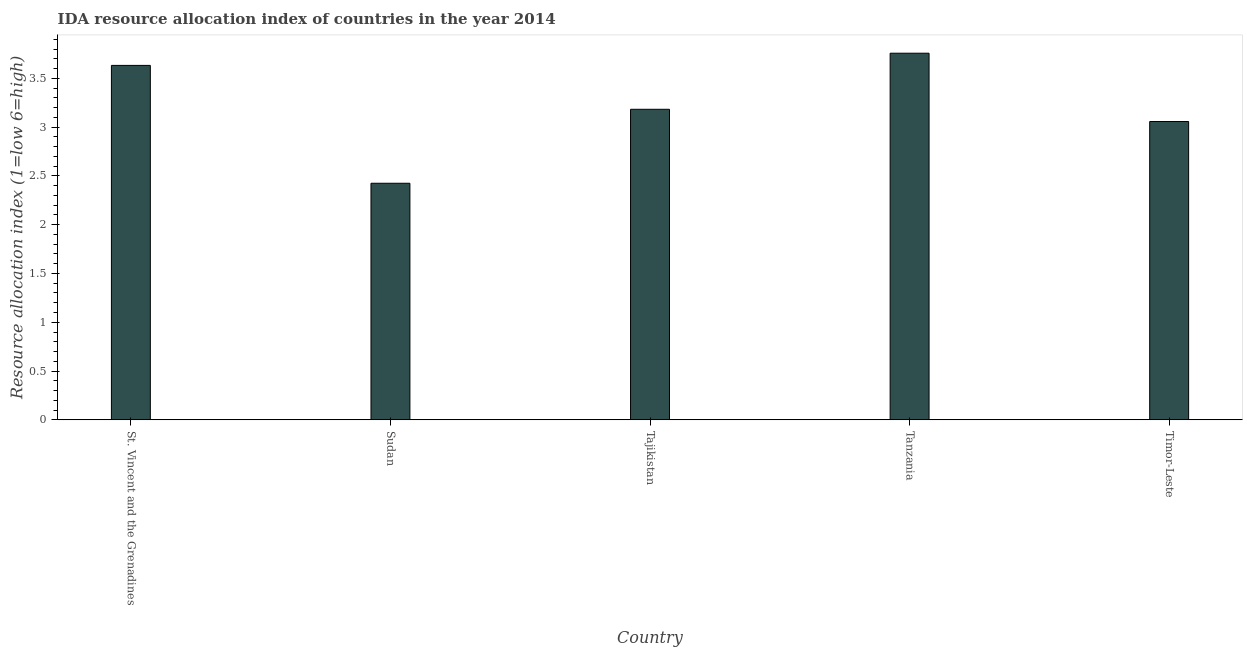Does the graph contain grids?
Give a very brief answer. No. What is the title of the graph?
Make the answer very short. IDA resource allocation index of countries in the year 2014. What is the label or title of the X-axis?
Your answer should be very brief. Country. What is the label or title of the Y-axis?
Make the answer very short. Resource allocation index (1=low 6=high). What is the ida resource allocation index in Sudan?
Your answer should be very brief. 2.42. Across all countries, what is the maximum ida resource allocation index?
Ensure brevity in your answer.  3.76. Across all countries, what is the minimum ida resource allocation index?
Provide a succinct answer. 2.42. In which country was the ida resource allocation index maximum?
Offer a terse response. Tanzania. In which country was the ida resource allocation index minimum?
Your response must be concise. Sudan. What is the sum of the ida resource allocation index?
Give a very brief answer. 16.06. What is the difference between the ida resource allocation index in Tajikistan and Tanzania?
Offer a terse response. -0.57. What is the average ida resource allocation index per country?
Offer a terse response. 3.21. What is the median ida resource allocation index?
Your answer should be very brief. 3.18. What is the ratio of the ida resource allocation index in Sudan to that in Timor-Leste?
Make the answer very short. 0.79. Is the ida resource allocation index in St. Vincent and the Grenadines less than that in Tajikistan?
Give a very brief answer. No. What is the difference between the highest and the second highest ida resource allocation index?
Offer a very short reply. 0.12. Is the sum of the ida resource allocation index in Sudan and Tajikistan greater than the maximum ida resource allocation index across all countries?
Offer a very short reply. Yes. What is the difference between the highest and the lowest ida resource allocation index?
Provide a succinct answer. 1.33. How many bars are there?
Provide a succinct answer. 5. Are all the bars in the graph horizontal?
Your answer should be very brief. No. What is the Resource allocation index (1=low 6=high) in St. Vincent and the Grenadines?
Keep it short and to the point. 3.63. What is the Resource allocation index (1=low 6=high) of Sudan?
Offer a very short reply. 2.42. What is the Resource allocation index (1=low 6=high) in Tajikistan?
Ensure brevity in your answer.  3.18. What is the Resource allocation index (1=low 6=high) in Tanzania?
Offer a terse response. 3.76. What is the Resource allocation index (1=low 6=high) of Timor-Leste?
Offer a very short reply. 3.06. What is the difference between the Resource allocation index (1=low 6=high) in St. Vincent and the Grenadines and Sudan?
Make the answer very short. 1.21. What is the difference between the Resource allocation index (1=low 6=high) in St. Vincent and the Grenadines and Tajikistan?
Your answer should be compact. 0.45. What is the difference between the Resource allocation index (1=low 6=high) in St. Vincent and the Grenadines and Tanzania?
Provide a succinct answer. -0.12. What is the difference between the Resource allocation index (1=low 6=high) in St. Vincent and the Grenadines and Timor-Leste?
Your answer should be compact. 0.57. What is the difference between the Resource allocation index (1=low 6=high) in Sudan and Tajikistan?
Provide a succinct answer. -0.76. What is the difference between the Resource allocation index (1=low 6=high) in Sudan and Tanzania?
Make the answer very short. -1.33. What is the difference between the Resource allocation index (1=low 6=high) in Sudan and Timor-Leste?
Make the answer very short. -0.63. What is the difference between the Resource allocation index (1=low 6=high) in Tajikistan and Tanzania?
Your answer should be compact. -0.57. What is the ratio of the Resource allocation index (1=low 6=high) in St. Vincent and the Grenadines to that in Sudan?
Provide a succinct answer. 1.5. What is the ratio of the Resource allocation index (1=low 6=high) in St. Vincent and the Grenadines to that in Tajikistan?
Your response must be concise. 1.14. What is the ratio of the Resource allocation index (1=low 6=high) in St. Vincent and the Grenadines to that in Tanzania?
Your answer should be compact. 0.97. What is the ratio of the Resource allocation index (1=low 6=high) in St. Vincent and the Grenadines to that in Timor-Leste?
Your answer should be compact. 1.19. What is the ratio of the Resource allocation index (1=low 6=high) in Sudan to that in Tajikistan?
Offer a terse response. 0.76. What is the ratio of the Resource allocation index (1=low 6=high) in Sudan to that in Tanzania?
Give a very brief answer. 0.65. What is the ratio of the Resource allocation index (1=low 6=high) in Sudan to that in Timor-Leste?
Your answer should be very brief. 0.79. What is the ratio of the Resource allocation index (1=low 6=high) in Tajikistan to that in Tanzania?
Ensure brevity in your answer.  0.85. What is the ratio of the Resource allocation index (1=low 6=high) in Tajikistan to that in Timor-Leste?
Your answer should be very brief. 1.04. What is the ratio of the Resource allocation index (1=low 6=high) in Tanzania to that in Timor-Leste?
Keep it short and to the point. 1.23. 